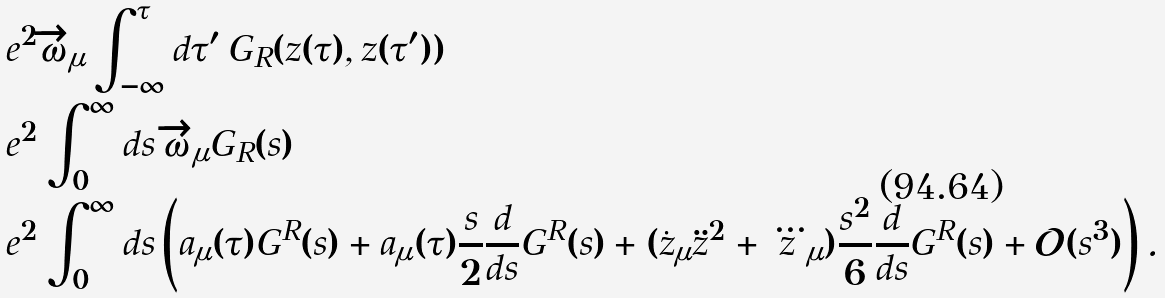Convert formula to latex. <formula><loc_0><loc_0><loc_500><loc_500>& e ^ { 2 } \overrightarrow { \omega } _ { \mu } \int _ { - \infty } ^ { \tau } d \tau ^ { \prime } \, G _ { R } ( z ( \tau ) , z ( \tau ^ { \prime } ) ) \\ = & e ^ { 2 } \int _ { 0 } ^ { \infty } d s \, \overrightarrow { \omega } _ { \mu } G _ { R } ( s ) \\ = & e ^ { 2 } \int ^ { \infty } _ { 0 } d s \left ( a _ { \mu } ( \tau ) G ^ { R } ( s ) + a _ { \mu } ( \tau ) \frac { s } { 2 } \frac { d } { d s } G ^ { R } ( s ) + ( \dot { z } _ { \mu } \ddot { z } ^ { 2 } + \dddot { z } _ { \mu } ) \frac { s ^ { 2 } } { 6 } \frac { d } { d s } G ^ { R } ( s ) + \mathcal { O } ( s ^ { 3 } ) \right ) .</formula> 